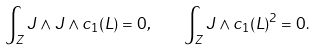Convert formula to latex. <formula><loc_0><loc_0><loc_500><loc_500>\int _ { Z } J \wedge J \wedge c _ { 1 } ( L ) = 0 , \quad \int _ { Z } J \wedge c _ { 1 } ( L ) ^ { 2 } = 0 .</formula> 